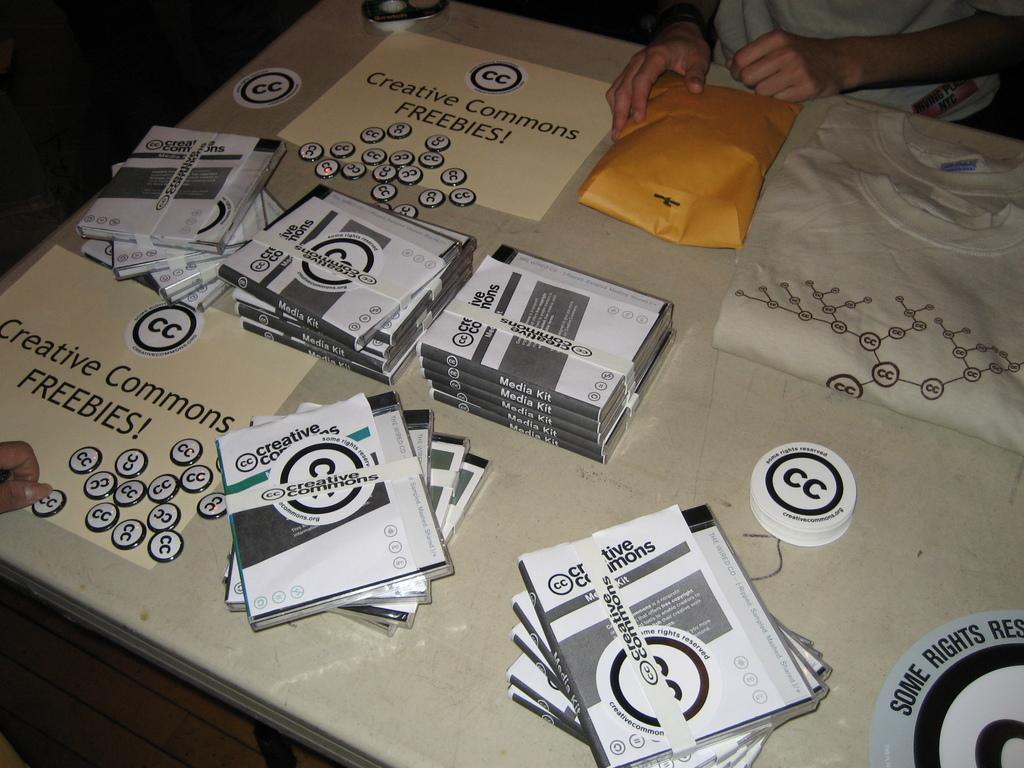In one or two sentences, can you explain what this image depicts? In this picture I can see a table in front, on which there are coins, number of boxes and I can see 2 t-shirts. I can also see something is written on the table and I see 2 persons. On the center top of this picture I can see an orange color thing. 